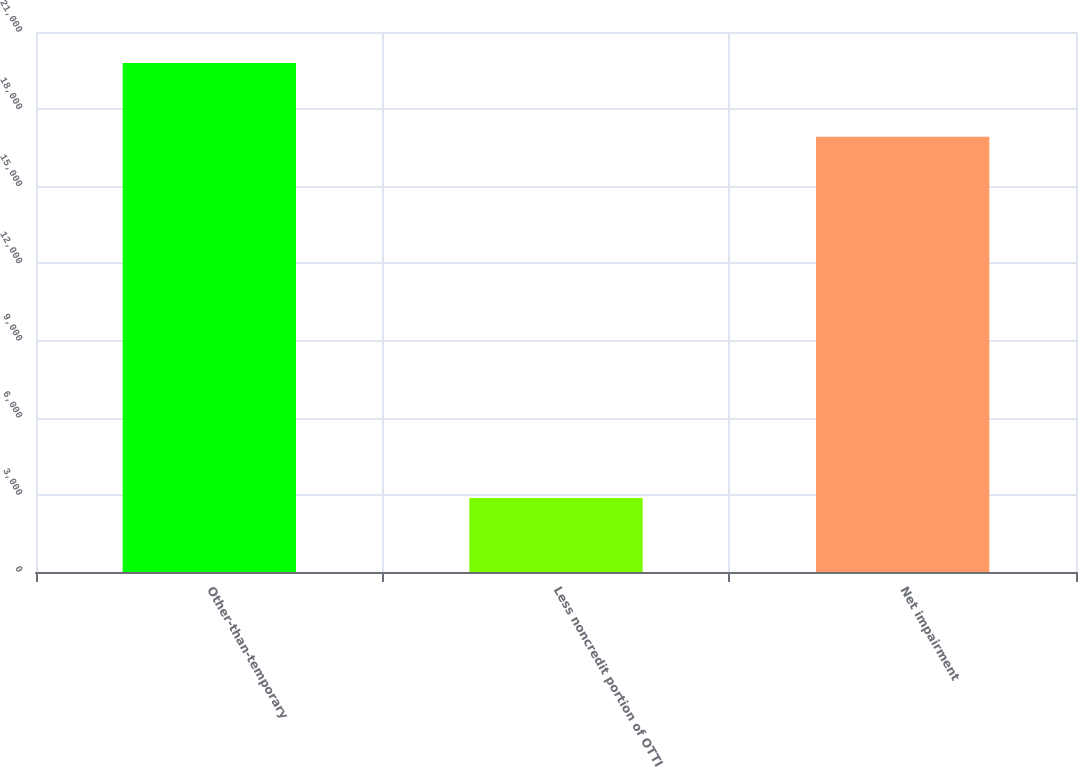<chart> <loc_0><loc_0><loc_500><loc_500><bar_chart><fcel>Other-than-temporary<fcel>Less noncredit portion of OTTI<fcel>Net impairment<nl><fcel>19799<fcel>2874<fcel>16925<nl></chart> 